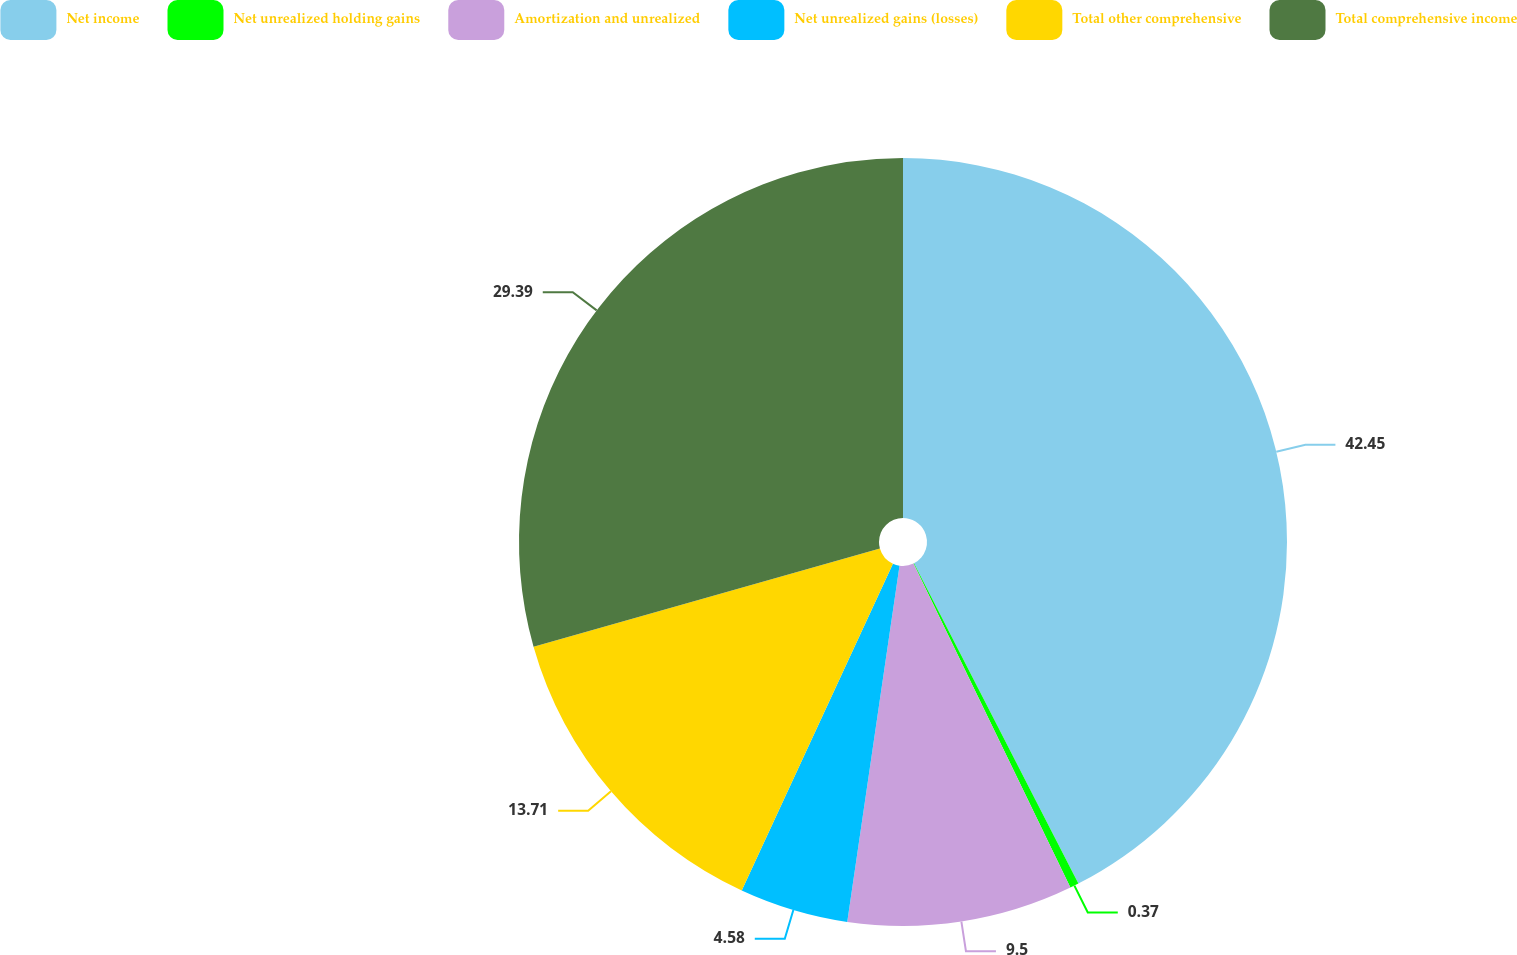Convert chart to OTSL. <chart><loc_0><loc_0><loc_500><loc_500><pie_chart><fcel>Net income<fcel>Net unrealized holding gains<fcel>Amortization and unrealized<fcel>Net unrealized gains (losses)<fcel>Total other comprehensive<fcel>Total comprehensive income<nl><fcel>42.46%<fcel>0.37%<fcel>9.5%<fcel>4.58%<fcel>13.71%<fcel>29.4%<nl></chart> 